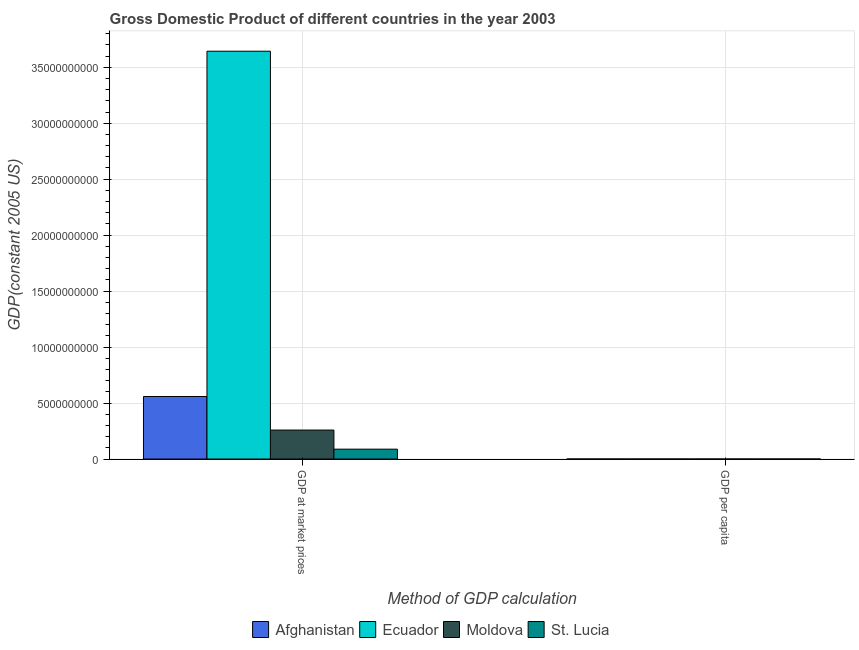How many different coloured bars are there?
Your answer should be very brief. 4. Are the number of bars per tick equal to the number of legend labels?
Offer a very short reply. Yes. Are the number of bars on each tick of the X-axis equal?
Provide a short and direct response. Yes. How many bars are there on the 2nd tick from the right?
Provide a succinct answer. 4. What is the label of the 2nd group of bars from the left?
Ensure brevity in your answer.  GDP per capita. What is the gdp at market prices in Moldova?
Your response must be concise. 2.59e+09. Across all countries, what is the maximum gdp at market prices?
Offer a terse response. 3.64e+1. Across all countries, what is the minimum gdp at market prices?
Keep it short and to the point. 8.82e+08. In which country was the gdp at market prices maximum?
Provide a short and direct response. Ecuador. In which country was the gdp per capita minimum?
Your response must be concise. Afghanistan. What is the total gdp per capita in the graph?
Make the answer very short. 9156.58. What is the difference between the gdp per capita in Moldova and that in St. Lucia?
Provide a short and direct response. -4734.32. What is the difference between the gdp at market prices in Afghanistan and the gdp per capita in St. Lucia?
Offer a terse response. 5.59e+09. What is the average gdp at market prices per country?
Provide a succinct answer. 1.14e+1. What is the difference between the gdp per capita and gdp at market prices in Moldova?
Make the answer very short. -2.59e+09. In how many countries, is the gdp at market prices greater than 37000000000 US$?
Offer a terse response. 0. What is the ratio of the gdp per capita in Afghanistan to that in Moldova?
Give a very brief answer. 0.35. Is the gdp per capita in St. Lucia less than that in Ecuador?
Offer a very short reply. No. In how many countries, is the gdp per capita greater than the average gdp per capita taken over all countries?
Offer a very short reply. 2. What does the 3rd bar from the left in GDP per capita represents?
Ensure brevity in your answer.  Moldova. What does the 4th bar from the right in GDP at market prices represents?
Keep it short and to the point. Afghanistan. How many countries are there in the graph?
Ensure brevity in your answer.  4. What is the difference between two consecutive major ticks on the Y-axis?
Make the answer very short. 5.00e+09. Are the values on the major ticks of Y-axis written in scientific E-notation?
Your response must be concise. No. Does the graph contain grids?
Offer a very short reply. Yes. Where does the legend appear in the graph?
Offer a terse response. Bottom center. What is the title of the graph?
Your response must be concise. Gross Domestic Product of different countries in the year 2003. What is the label or title of the X-axis?
Your answer should be compact. Method of GDP calculation. What is the label or title of the Y-axis?
Make the answer very short. GDP(constant 2005 US). What is the GDP(constant 2005 US) in Afghanistan in GDP at market prices?
Make the answer very short. 5.59e+09. What is the GDP(constant 2005 US) of Ecuador in GDP at market prices?
Ensure brevity in your answer.  3.64e+1. What is the GDP(constant 2005 US) in Moldova in GDP at market prices?
Ensure brevity in your answer.  2.59e+09. What is the GDP(constant 2005 US) of St. Lucia in GDP at market prices?
Keep it short and to the point. 8.82e+08. What is the GDP(constant 2005 US) in Afghanistan in GDP per capita?
Your answer should be very brief. 248.16. What is the GDP(constant 2005 US) in Ecuador in GDP per capita?
Give a very brief answer. 2741.24. What is the GDP(constant 2005 US) of Moldova in GDP per capita?
Provide a short and direct response. 716.43. What is the GDP(constant 2005 US) of St. Lucia in GDP per capita?
Provide a succinct answer. 5450.76. Across all Method of GDP calculation, what is the maximum GDP(constant 2005 US) of Afghanistan?
Offer a terse response. 5.59e+09. Across all Method of GDP calculation, what is the maximum GDP(constant 2005 US) in Ecuador?
Your answer should be very brief. 3.64e+1. Across all Method of GDP calculation, what is the maximum GDP(constant 2005 US) of Moldova?
Your answer should be compact. 2.59e+09. Across all Method of GDP calculation, what is the maximum GDP(constant 2005 US) of St. Lucia?
Provide a short and direct response. 8.82e+08. Across all Method of GDP calculation, what is the minimum GDP(constant 2005 US) in Afghanistan?
Offer a terse response. 248.16. Across all Method of GDP calculation, what is the minimum GDP(constant 2005 US) of Ecuador?
Give a very brief answer. 2741.24. Across all Method of GDP calculation, what is the minimum GDP(constant 2005 US) of Moldova?
Offer a very short reply. 716.43. Across all Method of GDP calculation, what is the minimum GDP(constant 2005 US) of St. Lucia?
Make the answer very short. 5450.76. What is the total GDP(constant 2005 US) of Afghanistan in the graph?
Provide a succinct answer. 5.59e+09. What is the total GDP(constant 2005 US) in Ecuador in the graph?
Keep it short and to the point. 3.64e+1. What is the total GDP(constant 2005 US) of Moldova in the graph?
Offer a terse response. 2.59e+09. What is the total GDP(constant 2005 US) in St. Lucia in the graph?
Give a very brief answer. 8.82e+08. What is the difference between the GDP(constant 2005 US) in Afghanistan in GDP at market prices and that in GDP per capita?
Provide a short and direct response. 5.59e+09. What is the difference between the GDP(constant 2005 US) in Ecuador in GDP at market prices and that in GDP per capita?
Offer a terse response. 3.64e+1. What is the difference between the GDP(constant 2005 US) in Moldova in GDP at market prices and that in GDP per capita?
Provide a short and direct response. 2.59e+09. What is the difference between the GDP(constant 2005 US) of St. Lucia in GDP at market prices and that in GDP per capita?
Make the answer very short. 8.82e+08. What is the difference between the GDP(constant 2005 US) in Afghanistan in GDP at market prices and the GDP(constant 2005 US) in Ecuador in GDP per capita?
Keep it short and to the point. 5.59e+09. What is the difference between the GDP(constant 2005 US) in Afghanistan in GDP at market prices and the GDP(constant 2005 US) in Moldova in GDP per capita?
Give a very brief answer. 5.59e+09. What is the difference between the GDP(constant 2005 US) in Afghanistan in GDP at market prices and the GDP(constant 2005 US) in St. Lucia in GDP per capita?
Offer a terse response. 5.59e+09. What is the difference between the GDP(constant 2005 US) of Ecuador in GDP at market prices and the GDP(constant 2005 US) of Moldova in GDP per capita?
Your answer should be compact. 3.64e+1. What is the difference between the GDP(constant 2005 US) in Ecuador in GDP at market prices and the GDP(constant 2005 US) in St. Lucia in GDP per capita?
Provide a short and direct response. 3.64e+1. What is the difference between the GDP(constant 2005 US) of Moldova in GDP at market prices and the GDP(constant 2005 US) of St. Lucia in GDP per capita?
Provide a short and direct response. 2.59e+09. What is the average GDP(constant 2005 US) in Afghanistan per Method of GDP calculation?
Your answer should be compact. 2.79e+09. What is the average GDP(constant 2005 US) of Ecuador per Method of GDP calculation?
Keep it short and to the point. 1.82e+1. What is the average GDP(constant 2005 US) in Moldova per Method of GDP calculation?
Ensure brevity in your answer.  1.29e+09. What is the average GDP(constant 2005 US) in St. Lucia per Method of GDP calculation?
Offer a terse response. 4.41e+08. What is the difference between the GDP(constant 2005 US) in Afghanistan and GDP(constant 2005 US) in Ecuador in GDP at market prices?
Make the answer very short. -3.08e+1. What is the difference between the GDP(constant 2005 US) in Afghanistan and GDP(constant 2005 US) in Moldova in GDP at market prices?
Make the answer very short. 3.00e+09. What is the difference between the GDP(constant 2005 US) in Afghanistan and GDP(constant 2005 US) in St. Lucia in GDP at market prices?
Ensure brevity in your answer.  4.70e+09. What is the difference between the GDP(constant 2005 US) in Ecuador and GDP(constant 2005 US) in Moldova in GDP at market prices?
Offer a terse response. 3.38e+1. What is the difference between the GDP(constant 2005 US) in Ecuador and GDP(constant 2005 US) in St. Lucia in GDP at market prices?
Keep it short and to the point. 3.55e+1. What is the difference between the GDP(constant 2005 US) in Moldova and GDP(constant 2005 US) in St. Lucia in GDP at market prices?
Keep it short and to the point. 1.71e+09. What is the difference between the GDP(constant 2005 US) of Afghanistan and GDP(constant 2005 US) of Ecuador in GDP per capita?
Offer a very short reply. -2493.08. What is the difference between the GDP(constant 2005 US) of Afghanistan and GDP(constant 2005 US) of Moldova in GDP per capita?
Give a very brief answer. -468.28. What is the difference between the GDP(constant 2005 US) of Afghanistan and GDP(constant 2005 US) of St. Lucia in GDP per capita?
Provide a short and direct response. -5202.6. What is the difference between the GDP(constant 2005 US) of Ecuador and GDP(constant 2005 US) of Moldova in GDP per capita?
Offer a very short reply. 2024.8. What is the difference between the GDP(constant 2005 US) in Ecuador and GDP(constant 2005 US) in St. Lucia in GDP per capita?
Keep it short and to the point. -2709.52. What is the difference between the GDP(constant 2005 US) in Moldova and GDP(constant 2005 US) in St. Lucia in GDP per capita?
Your answer should be compact. -4734.32. What is the ratio of the GDP(constant 2005 US) in Afghanistan in GDP at market prices to that in GDP per capita?
Your response must be concise. 2.25e+07. What is the ratio of the GDP(constant 2005 US) of Ecuador in GDP at market prices to that in GDP per capita?
Your answer should be very brief. 1.33e+07. What is the ratio of the GDP(constant 2005 US) of Moldova in GDP at market prices to that in GDP per capita?
Offer a very short reply. 3.61e+06. What is the ratio of the GDP(constant 2005 US) of St. Lucia in GDP at market prices to that in GDP per capita?
Offer a very short reply. 1.62e+05. What is the difference between the highest and the second highest GDP(constant 2005 US) of Afghanistan?
Keep it short and to the point. 5.59e+09. What is the difference between the highest and the second highest GDP(constant 2005 US) in Ecuador?
Give a very brief answer. 3.64e+1. What is the difference between the highest and the second highest GDP(constant 2005 US) of Moldova?
Your answer should be very brief. 2.59e+09. What is the difference between the highest and the second highest GDP(constant 2005 US) of St. Lucia?
Keep it short and to the point. 8.82e+08. What is the difference between the highest and the lowest GDP(constant 2005 US) of Afghanistan?
Provide a short and direct response. 5.59e+09. What is the difference between the highest and the lowest GDP(constant 2005 US) of Ecuador?
Your answer should be very brief. 3.64e+1. What is the difference between the highest and the lowest GDP(constant 2005 US) in Moldova?
Provide a short and direct response. 2.59e+09. What is the difference between the highest and the lowest GDP(constant 2005 US) in St. Lucia?
Your answer should be very brief. 8.82e+08. 